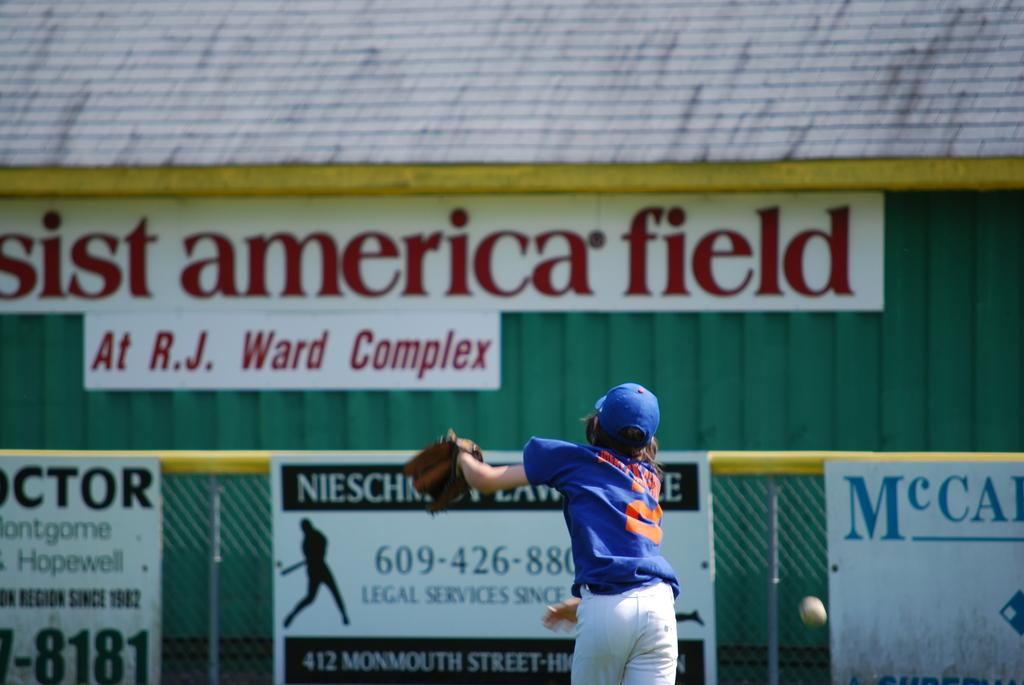<image>
Summarize the visual content of the image. A baseball player is trying to catch a ball under a sign that says America field. 